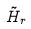<formula> <loc_0><loc_0><loc_500><loc_500>\tilde { H } _ { r }</formula> 